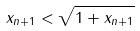Convert formula to latex. <formula><loc_0><loc_0><loc_500><loc_500>x _ { n + 1 } < \sqrt { 1 + x _ { n + 1 } }</formula> 